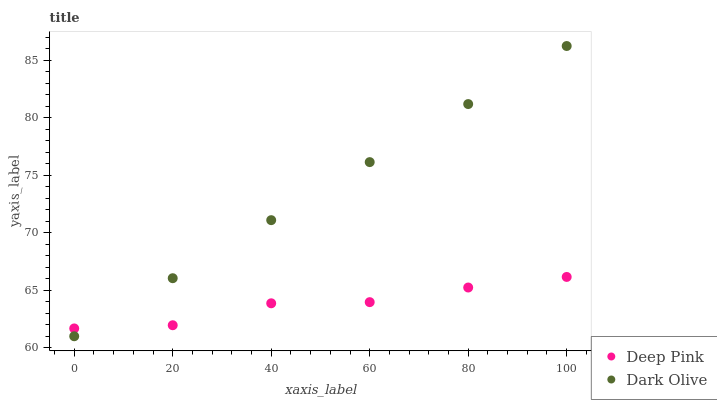Does Deep Pink have the minimum area under the curve?
Answer yes or no. Yes. Does Dark Olive have the maximum area under the curve?
Answer yes or no. Yes. Does Deep Pink have the maximum area under the curve?
Answer yes or no. No. Is Dark Olive the smoothest?
Answer yes or no. Yes. Is Deep Pink the roughest?
Answer yes or no. Yes. Is Deep Pink the smoothest?
Answer yes or no. No. Does Dark Olive have the lowest value?
Answer yes or no. Yes. Does Deep Pink have the lowest value?
Answer yes or no. No. Does Dark Olive have the highest value?
Answer yes or no. Yes. Does Deep Pink have the highest value?
Answer yes or no. No. Does Deep Pink intersect Dark Olive?
Answer yes or no. Yes. Is Deep Pink less than Dark Olive?
Answer yes or no. No. Is Deep Pink greater than Dark Olive?
Answer yes or no. No. 